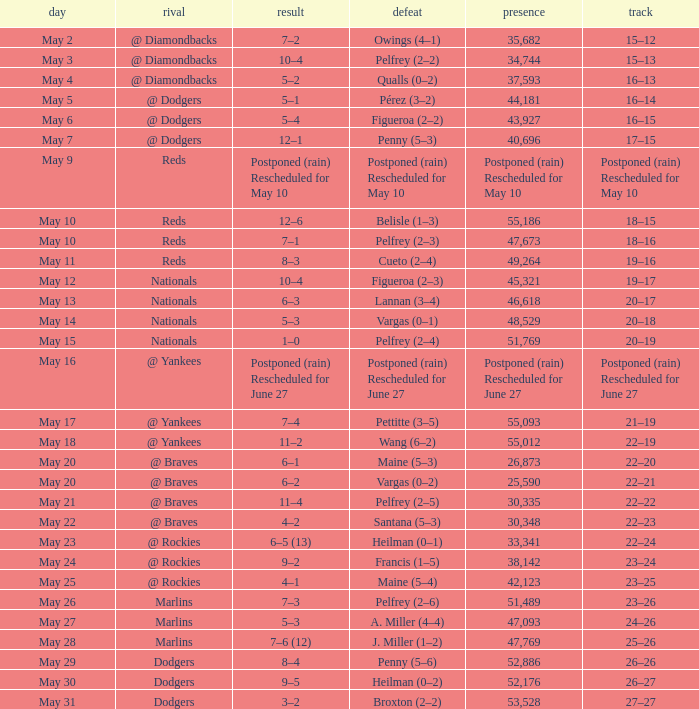Score of postponed (rain) rescheduled for June 27 had what loss? Postponed (rain) Rescheduled for June 27. 